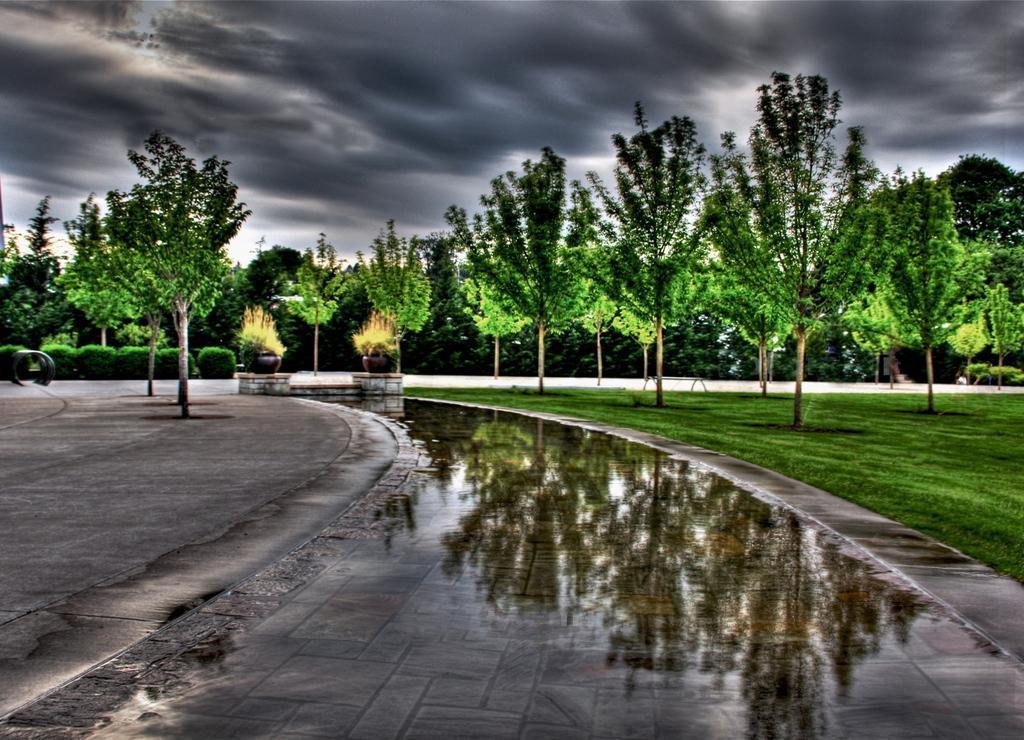Please provide a concise description of this image. In this image there are trees and plants. At the bottom there is water. In the background there is sky. 